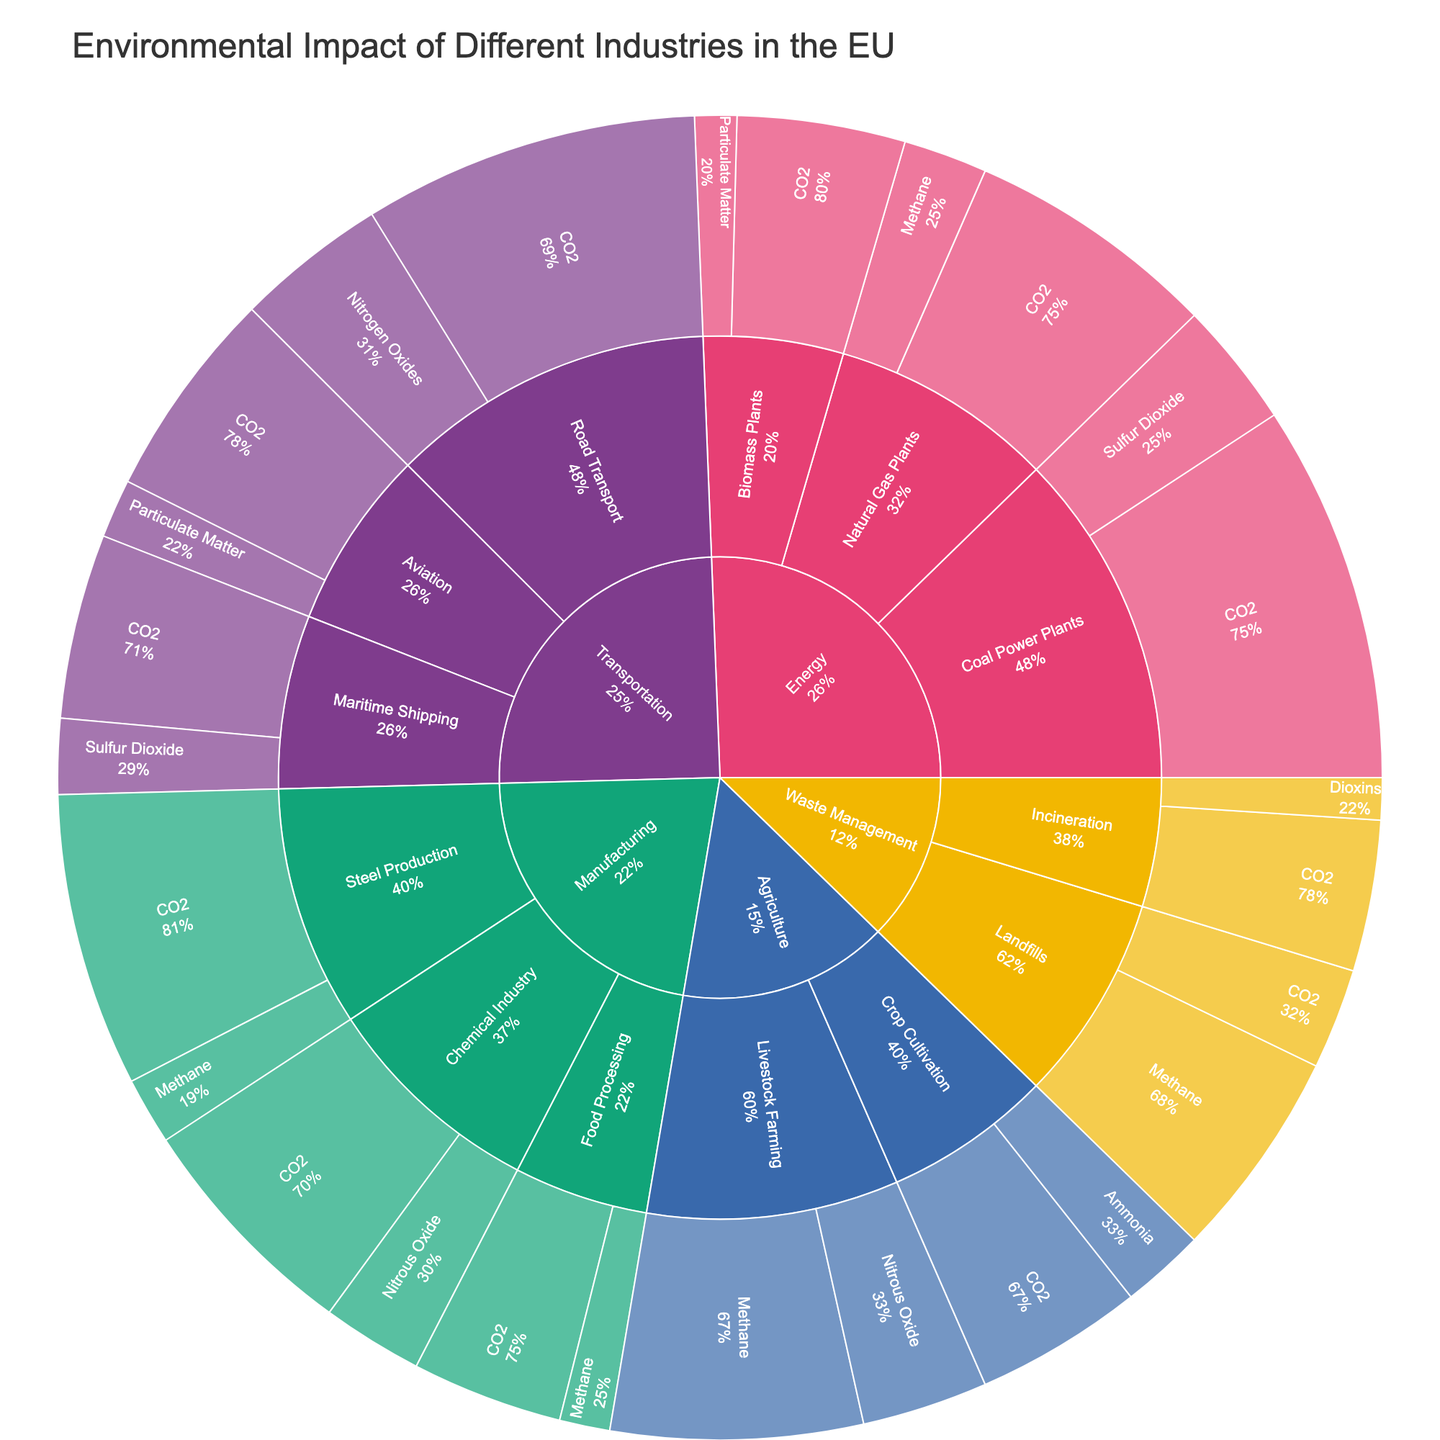What is the title of the sunburst plot? The title of the plot is displayed prominently at the top of the plot. It is "Environmental Impact of Different Industries in the EU."
Answer: Environmental Impact of Different Industries in the EU Which sector within Manufacturing has the highest CO2 emissions according to the plot? Observing the Manufacturing sector, Steel Production has a larger section for CO2 emissions compared to other sub-sectors.
Answer: Steel Production How does the CO2 emission value of Road Transport compare to that of Aviation in the Transportation sector? Comparing the two sections within the Transportation sector, Road Transport's CO2 emissions are higher (40) than those of Aviation (25).
Answer: Road Transport is higher What is the total CO2 emission value for all sectors within the Manufacturing industry? Sum the CO2 values for Steel Production (35), Chemical Industry (28), and Food Processing (18) within Manufacturing: 35 + 28 + 18 = 81.
Answer: 81 Based on the proportion of total emissions, which industry has a bigger share of Methane emissions: Agriculture or Waste Management? Agriculture has an outer ring section of Methane emissions (Livestock Farming) that is wider compared to Waste Management (Landfills). Agriculture's share is 30 compared to Waste Management's 25.
Answer: Agriculture What is the emission type with the smallest contribution within the Energy sector? Observing the sectors within Energy, the smallest section by value is Particulate Matter in Biomass Plants with a value of 5.
Answer: Particulate Matter Which industry has the highest diversity in emission types, indicated by the variety within each sector? The Energy industry shows the most diverse emission types across its sectors (CO2, Sulfur Dioxide, Methane, Particulate Matter) compared to other industries.
Answer: Energy What are the two emission types contributed by Incineration within Waste Management, and what are their values? Looking at the Incineration sector within Waste Management, the two emission types are CO2 with a value of 18 and Dioxins with a value of 5.
Answer: CO2: 18, Dioxins: 5 What is the combined value of Nitrous Oxide emissions from both Chemical Industry and Livestock Farming sectors? Within Manufacturing (Chemical Industry) and Agriculture (Livestock Farming), Nitrous Oxide values are 12 and 15 respectively. Summing them gives: 12 + 15 = 27.
Answer: 27 Which sector under Agriculture contributes to CO2 emissions and what is its specific contribution? Under the Agriculture industry, the Crop Cultivation sector contributes to CO2 emissions with a specific value of 20.
Answer: Crop Cultivation: 20 